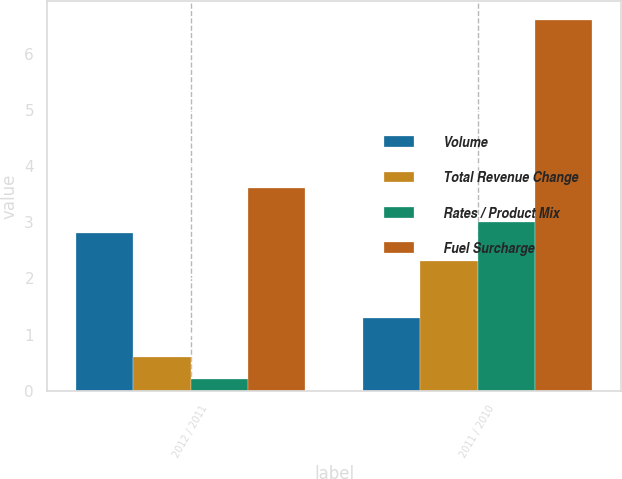Convert chart to OTSL. <chart><loc_0><loc_0><loc_500><loc_500><stacked_bar_chart><ecel><fcel>2012 / 2011<fcel>2011 / 2010<nl><fcel>Volume<fcel>2.8<fcel>1.3<nl><fcel>Total Revenue Change<fcel>0.6<fcel>2.3<nl><fcel>Rates / Product Mix<fcel>0.2<fcel>3<nl><fcel>Fuel Surcharge<fcel>3.6<fcel>6.6<nl></chart> 